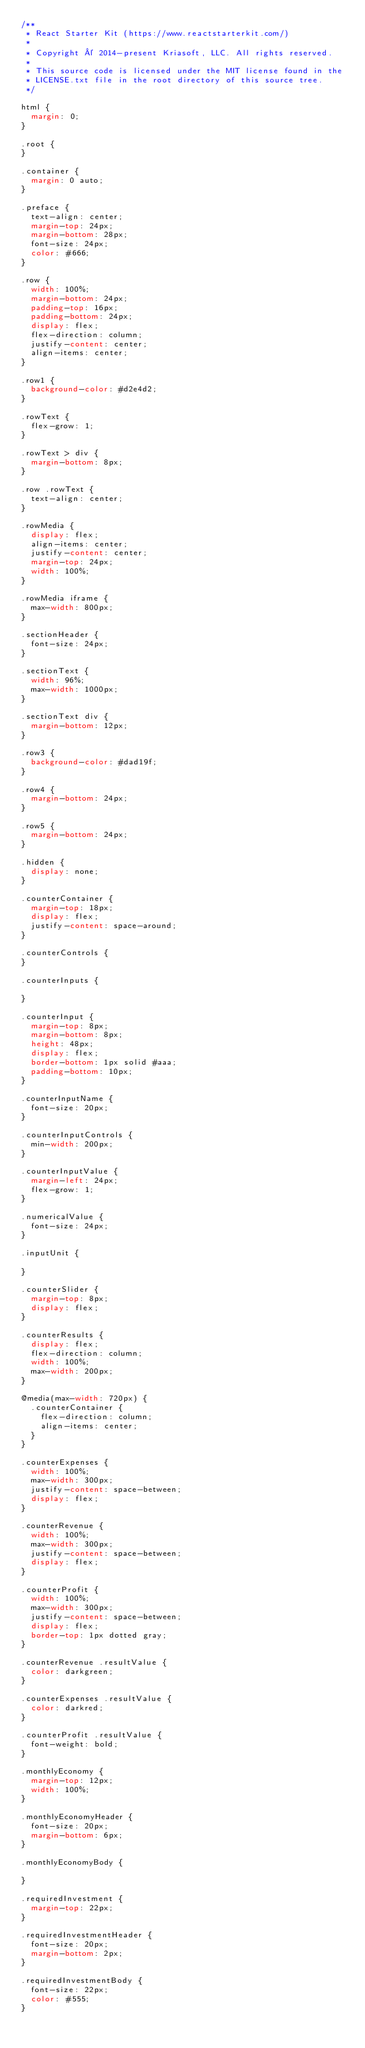Convert code to text. <code><loc_0><loc_0><loc_500><loc_500><_CSS_>/**
 * React Starter Kit (https://www.reactstarterkit.com/)
 *
 * Copyright © 2014-present Kriasoft, LLC. All rights reserved.
 *
 * This source code is licensed under the MIT license found in the
 * LICENSE.txt file in the root directory of this source tree.
 */

html {
  margin: 0;
}

.root {
}

.container {
  margin: 0 auto;
}

.preface {
  text-align: center;
  margin-top: 24px;
  margin-bottom: 28px;
  font-size: 24px;
  color: #666;
}

.row {
  width: 100%;
  margin-bottom: 24px;
  padding-top: 16px;
  padding-bottom: 24px;
  display: flex;
  flex-direction: column;
  justify-content: center;
  align-items: center;
}

.row1 {
  background-color: #d2e4d2;
}

.rowText {
  flex-grow: 1;
}

.rowText > div {
  margin-bottom: 8px;
}

.row .rowText {
  text-align: center;
}

.rowMedia {
  display: flex;
  align-items: center;
  justify-content: center;
  margin-top: 24px;
  width: 100%;
}

.rowMedia iframe {
  max-width: 800px;
}

.sectionHeader {
  font-size: 24px;
}

.sectionText {
  width: 96%;
  max-width: 1000px;
}

.sectionText div {
  margin-bottom: 12px;
}

.row3 {
  background-color: #dad19f;
}

.row4 {
  margin-bottom: 24px;
}

.row5 {
  margin-bottom: 24px;
}

.hidden {
  display: none;
}

.counterContainer {
  margin-top: 18px;
  display: flex;
  justify-content: space-around;
}

.counterControls {
}

.counterInputs {

}

.counterInput {
  margin-top: 8px;
  margin-bottom: 8px;
  height: 48px;
  display: flex;
  border-bottom: 1px solid #aaa;
  padding-bottom: 10px;
}

.counterInputName {
  font-size: 20px;
}

.counterInputControls {
  min-width: 200px;
}

.counterInputValue {
  margin-left: 24px;
  flex-grow: 1;
}

.numericalValue {
  font-size: 24px;
}

.inputUnit {

}

.counterSlider {
  margin-top: 8px;
  display: flex;
}

.counterResults {
  display: flex;
  flex-direction: column;
  width: 100%;
  max-width: 200px;
}

@media(max-width: 720px) {
  .counterContainer {
    flex-direction: column;
    align-items: center;
  }
}

.counterExpenses {
  width: 100%;
  max-width: 300px;
  justify-content: space-between;
  display: flex;
}

.counterRevenue {
  width: 100%;
  max-width: 300px;
  justify-content: space-between;
  display: flex;
}

.counterProfit {
  width: 100%;
  max-width: 300px;
  justify-content: space-between;
  display: flex;
  border-top: 1px dotted gray;
}

.counterRevenue .resultValue {
  color: darkgreen;
}

.counterExpenses .resultValue {
  color: darkred;
}

.counterProfit .resultValue {
  font-weight: bold;
}

.monthlyEconomy {
  margin-top: 12px;
  width: 100%;
}

.monthlyEconomyHeader {
  font-size: 20px;
  margin-bottom: 6px;
}

.monthlyEconomyBody {

}

.requiredInvestment {
  margin-top: 22px;
}

.requiredInvestmentHeader {
  font-size: 20px;
  margin-bottom: 2px;
}

.requiredInvestmentBody {
  font-size: 22px;
  color: #555;
}
</code> 